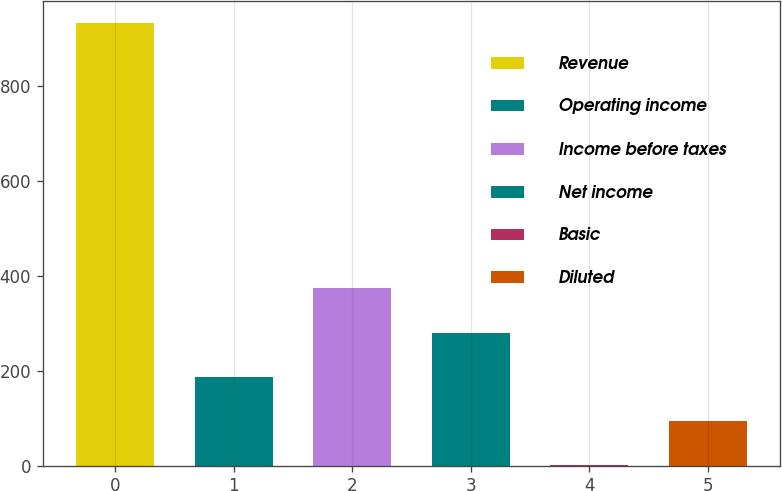Convert chart. <chart><loc_0><loc_0><loc_500><loc_500><bar_chart><fcel>Revenue<fcel>Operating income<fcel>Income before taxes<fcel>Net income<fcel>Basic<fcel>Diluted<nl><fcel>933<fcel>186.81<fcel>373.35<fcel>280.08<fcel>0.27<fcel>93.54<nl></chart> 